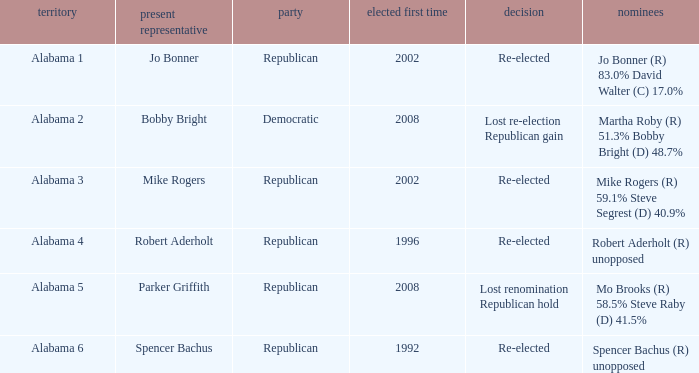Help me parse the entirety of this table. {'header': ['territory', 'present representative', 'party', 'elected first time', 'decision', 'nominees'], 'rows': [['Alabama 1', 'Jo Bonner', 'Republican', '2002', 'Re-elected', 'Jo Bonner (R) 83.0% David Walter (C) 17.0%'], ['Alabama 2', 'Bobby Bright', 'Democratic', '2008', 'Lost re-election Republican gain', 'Martha Roby (R) 51.3% Bobby Bright (D) 48.7%'], ['Alabama 3', 'Mike Rogers', 'Republican', '2002', 'Re-elected', 'Mike Rogers (R) 59.1% Steve Segrest (D) 40.9%'], ['Alabama 4', 'Robert Aderholt', 'Republican', '1996', 'Re-elected', 'Robert Aderholt (R) unopposed'], ['Alabama 5', 'Parker Griffith', 'Republican', '2008', 'Lost renomination Republican hold', 'Mo Brooks (R) 58.5% Steve Raby (D) 41.5%'], ['Alabama 6', 'Spencer Bachus', 'Republican', '1992', 'Re-elected', 'Spencer Bachus (R) unopposed']]} Name the incumbent for lost renomination republican hold Parker Griffith. 